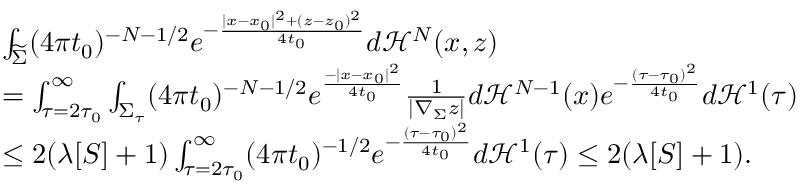Convert formula to latex. <formula><loc_0><loc_0><loc_500><loc_500>\begin{array} { r l } & { \int _ { \widetilde { \Sigma } } ( 4 \pi t _ { 0 } ) ^ { - { N - 1 } / 2 } e ^ { - \frac { | x - x _ { 0 } | ^ { 2 } + ( z - z _ { 0 } ) ^ { 2 } } { 4 t _ { 0 } } } d \mathcal { H } ^ { N } ( x , z ) } \\ & { = \int _ { \tau = 2 \tau _ { 0 } } ^ { \infty } \int _ { \Sigma _ { \tau } } ( 4 \pi t _ { 0 } ) ^ { - { N - 1 } / 2 } e ^ { \frac { - | x - x _ { 0 } | ^ { 2 } } { 4 t _ { 0 } } } \frac { 1 } { | \nabla _ { \Sigma } z | } d \mathcal { H } ^ { N - 1 } ( x ) e ^ { - \frac { ( \tau - \tau _ { 0 } ) ^ { 2 } } { 4 t _ { 0 } } } d \mathcal { H } ^ { 1 } ( \tau ) } \\ & { \leq 2 ( \lambda [ S ] + 1 ) \int _ { \tau = 2 \tau _ { 0 } } ^ { \infty } ( 4 \pi t _ { 0 } ) ^ { - 1 / 2 } e ^ { - \frac { ( \tau - \tau _ { 0 } ) ^ { 2 } } { 4 t _ { 0 } } } d \mathcal { H } ^ { 1 } ( \tau ) \leq 2 ( \lambda [ S ] + 1 ) . } \end{array}</formula> 